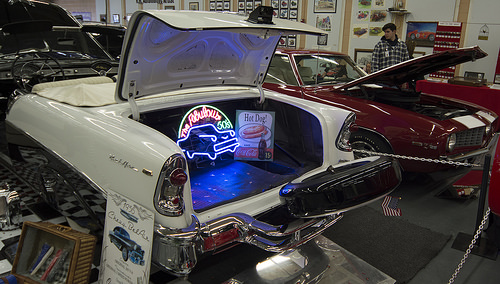<image>
Is the hood behind the man? No. The hood is not behind the man. From this viewpoint, the hood appears to be positioned elsewhere in the scene. Is there a hot dog in the car trunk? Yes. The hot dog is contained within or inside the car trunk, showing a containment relationship. Is there a sign in the trunk? Yes. The sign is contained within or inside the trunk, showing a containment relationship. 